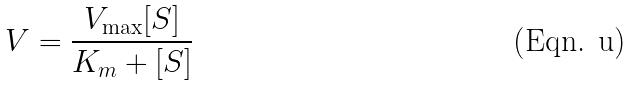<formula> <loc_0><loc_0><loc_500><loc_500>V = \frac { V _ { \max } [ S ] } { K _ { m } + [ S ] }</formula> 